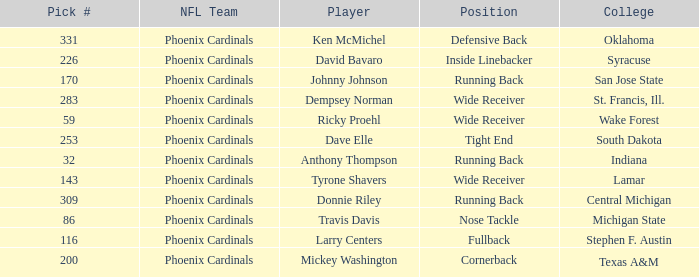Which NFL team has a pick# less than 200 for Travis Davis? Phoenix Cardinals. 